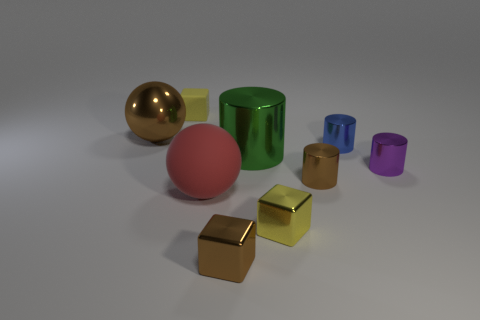Subtract all yellow blocks. How many were subtracted if there are1yellow blocks left? 1 Subtract all balls. How many objects are left? 7 Add 1 small brown metal cubes. How many small brown metal cubes are left? 2 Add 9 tiny blue matte objects. How many tiny blue matte objects exist? 9 Subtract 0 cyan balls. How many objects are left? 9 Subtract all brown shiny blocks. Subtract all blue metallic cylinders. How many objects are left? 7 